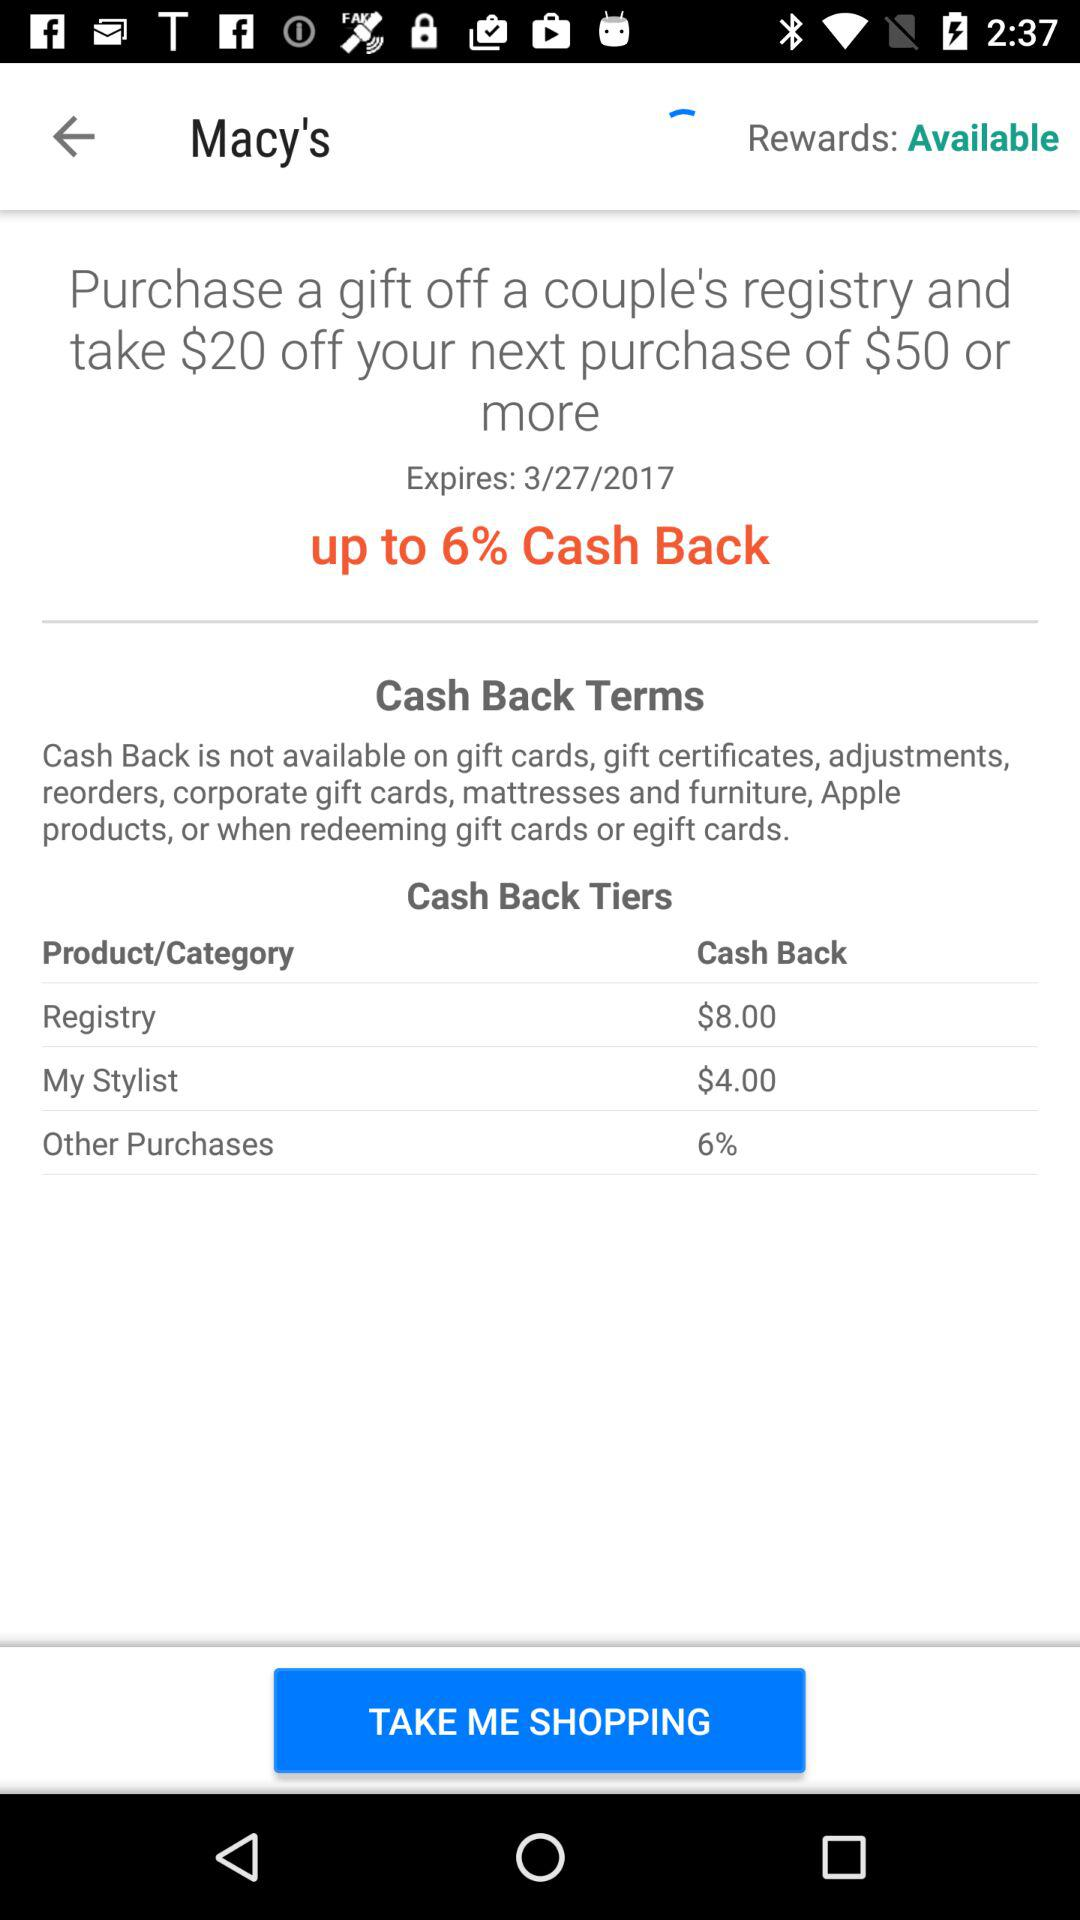How much discount will we get on our next purchase of $50 or more after purchasing a gift off a couple's registry? You will get a discount of $20 on your next purchase of $50 or more after purchasing a gift off a couple's registry. 